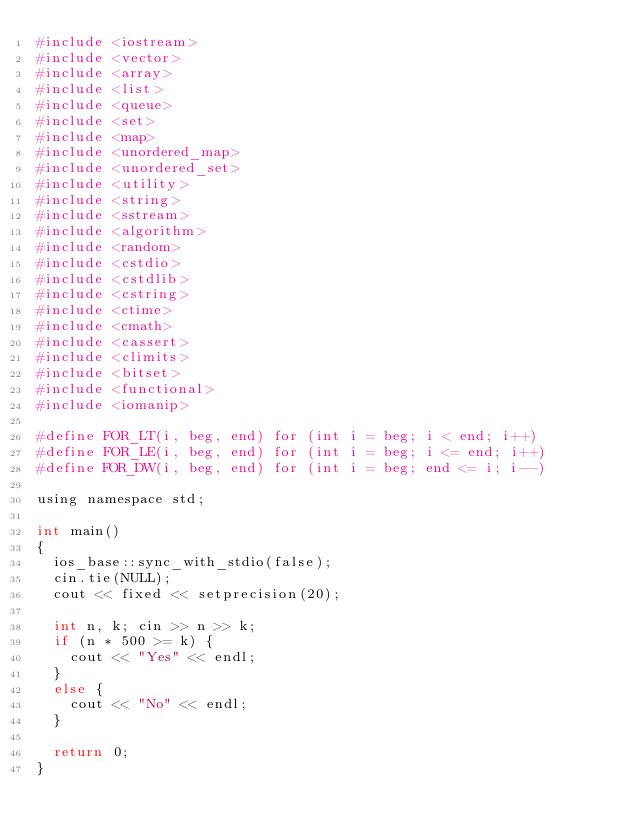<code> <loc_0><loc_0><loc_500><loc_500><_Python_>#include <iostream>
#include <vector>
#include <array>
#include <list>
#include <queue>
#include <set>
#include <map>
#include <unordered_map>
#include <unordered_set>
#include <utility>
#include <string>
#include <sstream>
#include <algorithm>
#include <random>
#include <cstdio>
#include <cstdlib>
#include <cstring>
#include <ctime>
#include <cmath>
#include <cassert>
#include <climits>
#include <bitset>
#include <functional>
#include <iomanip>

#define FOR_LT(i, beg, end) for (int i = beg; i < end; i++)
#define FOR_LE(i, beg, end) for (int i = beg; i <= end; i++)
#define FOR_DW(i, beg, end) for (int i = beg; end <= i; i--)

using namespace std;

int main()
{
	ios_base::sync_with_stdio(false);
	cin.tie(NULL);
	cout << fixed << setprecision(20);

	int n, k; cin >> n >> k;
	if (n * 500 >= k) {
		cout << "Yes" << endl;
	}
	else {
		cout << "No" << endl;
	}

	return 0;
}</code> 